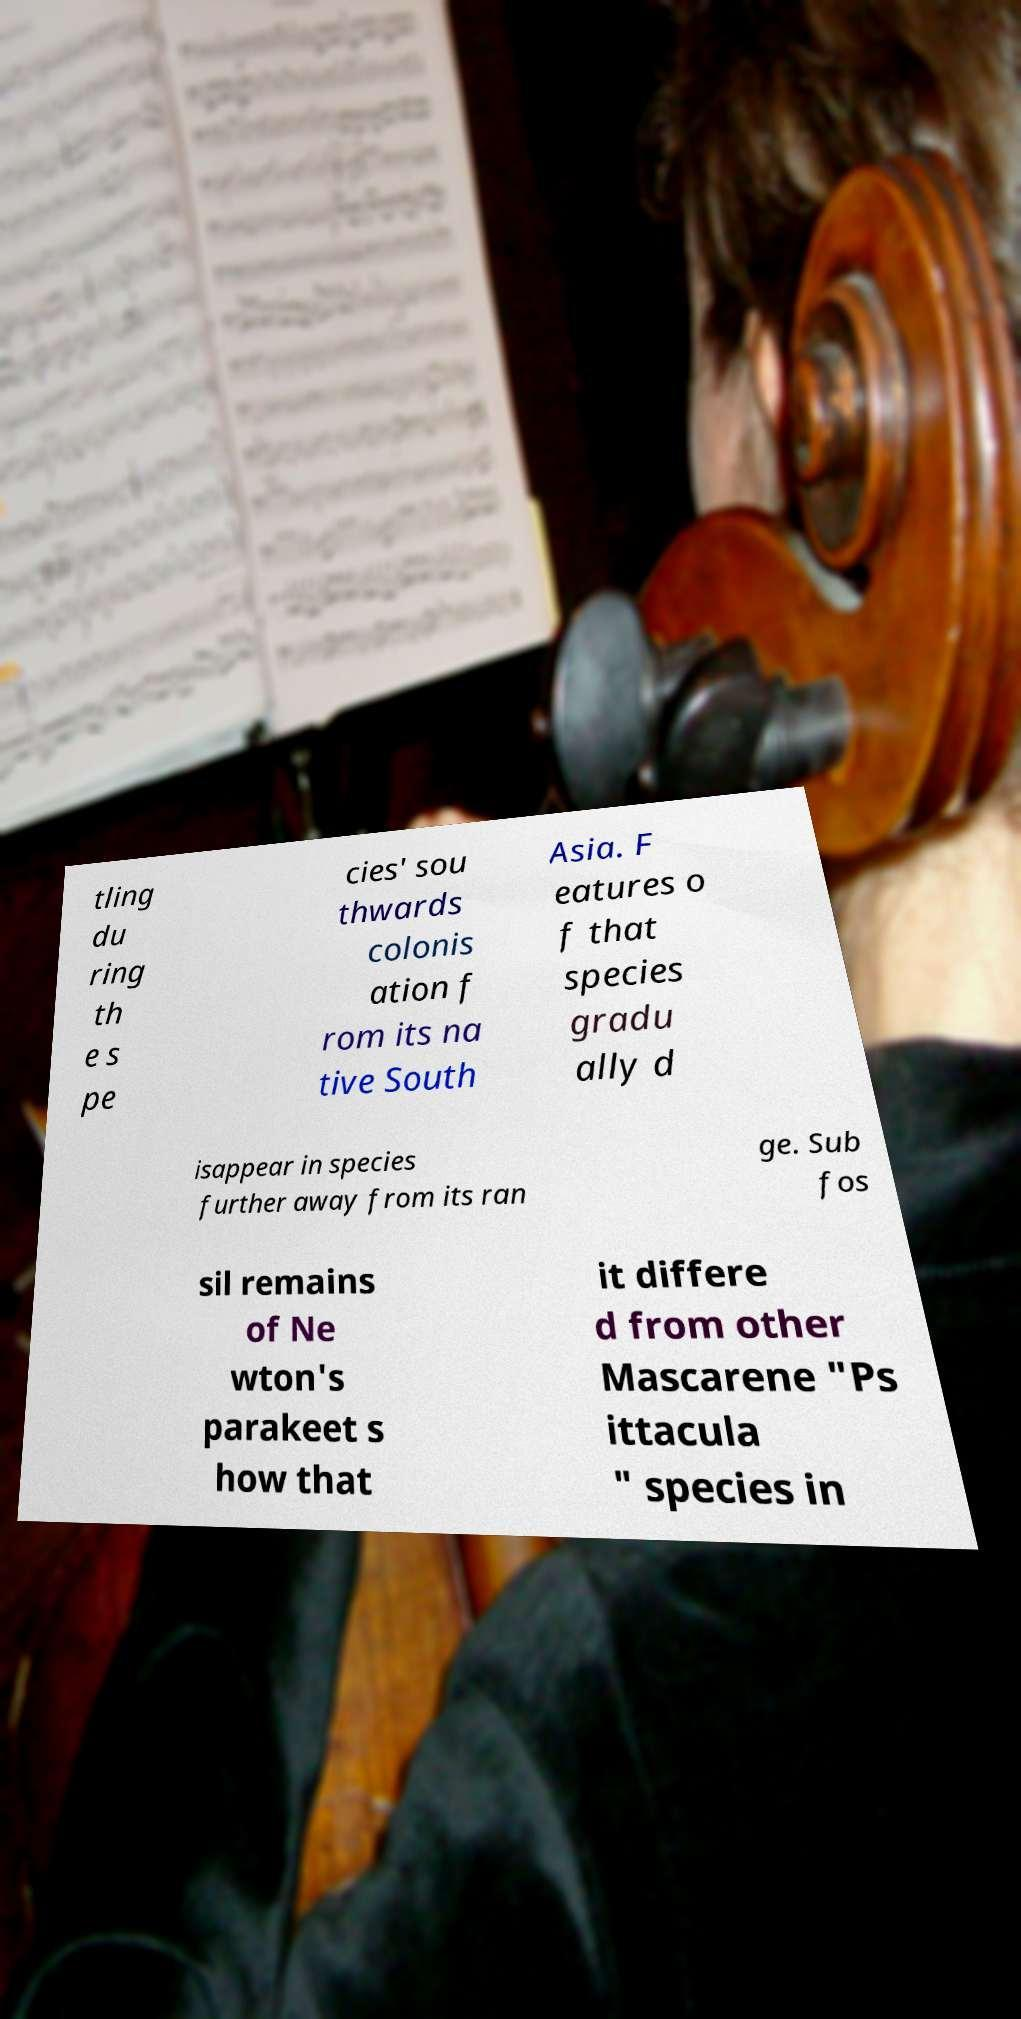Please read and relay the text visible in this image. What does it say? tling du ring th e s pe cies' sou thwards colonis ation f rom its na tive South Asia. F eatures o f that species gradu ally d isappear in species further away from its ran ge. Sub fos sil remains of Ne wton's parakeet s how that it differe d from other Mascarene "Ps ittacula " species in 